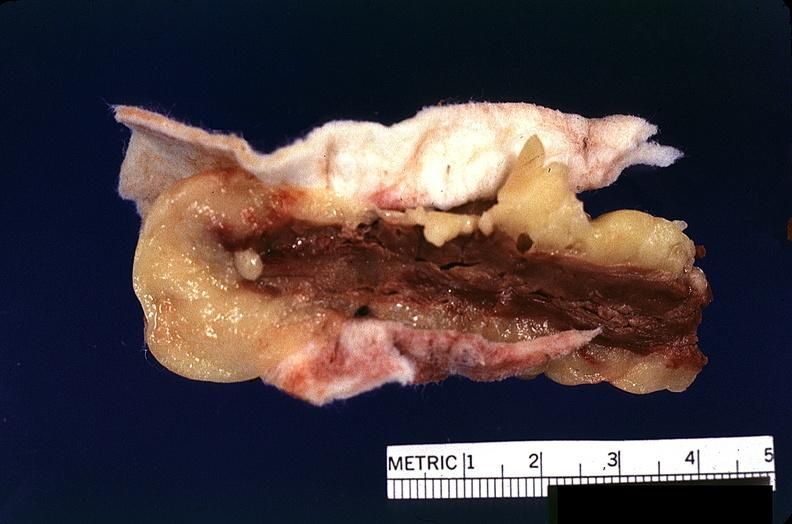does breast show heart, myocardial infarction, surgery to repair interventricular septum rupture?
Answer the question using a single word or phrase. No 